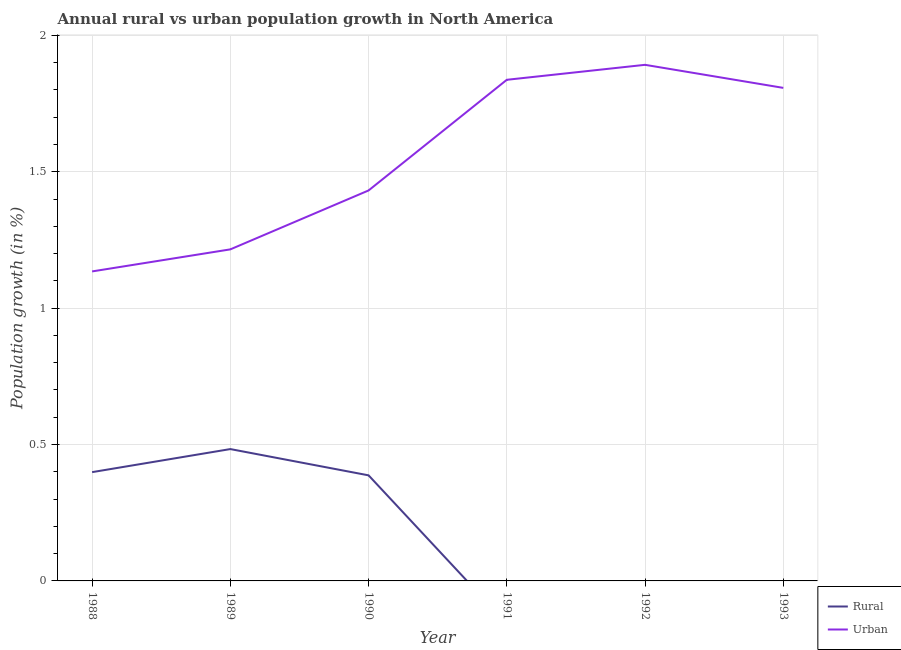Does the line corresponding to rural population growth intersect with the line corresponding to urban population growth?
Offer a terse response. No. What is the urban population growth in 1991?
Offer a very short reply. 1.84. Across all years, what is the maximum urban population growth?
Offer a terse response. 1.89. Across all years, what is the minimum rural population growth?
Your answer should be compact. 0. What is the total urban population growth in the graph?
Provide a succinct answer. 9.32. What is the difference between the urban population growth in 1989 and that in 1992?
Your answer should be very brief. -0.68. What is the difference between the rural population growth in 1990 and the urban population growth in 1992?
Give a very brief answer. -1.5. What is the average urban population growth per year?
Your answer should be compact. 1.55. In the year 1990, what is the difference between the rural population growth and urban population growth?
Your answer should be compact. -1.04. What is the ratio of the rural population growth in 1989 to that in 1990?
Your answer should be very brief. 1.25. Is the urban population growth in 1988 less than that in 1990?
Make the answer very short. Yes. What is the difference between the highest and the second highest urban population growth?
Provide a short and direct response. 0.05. What is the difference between the highest and the lowest rural population growth?
Your answer should be very brief. 0.48. In how many years, is the urban population growth greater than the average urban population growth taken over all years?
Provide a succinct answer. 3. Is the sum of the rural population growth in 1989 and 1990 greater than the maximum urban population growth across all years?
Make the answer very short. No. How many lines are there?
Offer a terse response. 2. How many years are there in the graph?
Keep it short and to the point. 6. Where does the legend appear in the graph?
Your answer should be compact. Bottom right. How are the legend labels stacked?
Ensure brevity in your answer.  Vertical. What is the title of the graph?
Your response must be concise. Annual rural vs urban population growth in North America. Does "Primary school" appear as one of the legend labels in the graph?
Make the answer very short. No. What is the label or title of the X-axis?
Your answer should be compact. Year. What is the label or title of the Y-axis?
Keep it short and to the point. Population growth (in %). What is the Population growth (in %) of Rural in 1988?
Provide a short and direct response. 0.4. What is the Population growth (in %) of Urban  in 1988?
Provide a succinct answer. 1.13. What is the Population growth (in %) in Rural in 1989?
Give a very brief answer. 0.48. What is the Population growth (in %) of Urban  in 1989?
Your answer should be very brief. 1.22. What is the Population growth (in %) in Rural in 1990?
Offer a terse response. 0.39. What is the Population growth (in %) in Urban  in 1990?
Offer a terse response. 1.43. What is the Population growth (in %) of Urban  in 1991?
Ensure brevity in your answer.  1.84. What is the Population growth (in %) in Rural in 1992?
Provide a succinct answer. 0. What is the Population growth (in %) in Urban  in 1992?
Offer a very short reply. 1.89. What is the Population growth (in %) of Rural in 1993?
Give a very brief answer. 0. What is the Population growth (in %) of Urban  in 1993?
Your answer should be compact. 1.81. Across all years, what is the maximum Population growth (in %) in Rural?
Offer a very short reply. 0.48. Across all years, what is the maximum Population growth (in %) in Urban ?
Provide a succinct answer. 1.89. Across all years, what is the minimum Population growth (in %) in Urban ?
Make the answer very short. 1.13. What is the total Population growth (in %) in Rural in the graph?
Keep it short and to the point. 1.27. What is the total Population growth (in %) of Urban  in the graph?
Make the answer very short. 9.32. What is the difference between the Population growth (in %) of Rural in 1988 and that in 1989?
Your answer should be compact. -0.08. What is the difference between the Population growth (in %) of Urban  in 1988 and that in 1989?
Your answer should be compact. -0.08. What is the difference between the Population growth (in %) of Rural in 1988 and that in 1990?
Your answer should be very brief. 0.01. What is the difference between the Population growth (in %) of Urban  in 1988 and that in 1990?
Ensure brevity in your answer.  -0.3. What is the difference between the Population growth (in %) in Urban  in 1988 and that in 1991?
Offer a terse response. -0.7. What is the difference between the Population growth (in %) in Urban  in 1988 and that in 1992?
Make the answer very short. -0.76. What is the difference between the Population growth (in %) in Urban  in 1988 and that in 1993?
Your answer should be compact. -0.67. What is the difference between the Population growth (in %) of Rural in 1989 and that in 1990?
Provide a short and direct response. 0.1. What is the difference between the Population growth (in %) in Urban  in 1989 and that in 1990?
Your answer should be compact. -0.22. What is the difference between the Population growth (in %) of Urban  in 1989 and that in 1991?
Ensure brevity in your answer.  -0.62. What is the difference between the Population growth (in %) of Urban  in 1989 and that in 1992?
Offer a very short reply. -0.68. What is the difference between the Population growth (in %) of Urban  in 1989 and that in 1993?
Provide a succinct answer. -0.59. What is the difference between the Population growth (in %) in Urban  in 1990 and that in 1991?
Your answer should be very brief. -0.41. What is the difference between the Population growth (in %) of Urban  in 1990 and that in 1992?
Keep it short and to the point. -0.46. What is the difference between the Population growth (in %) of Urban  in 1990 and that in 1993?
Offer a terse response. -0.38. What is the difference between the Population growth (in %) of Urban  in 1991 and that in 1992?
Make the answer very short. -0.05. What is the difference between the Population growth (in %) of Urban  in 1991 and that in 1993?
Your response must be concise. 0.03. What is the difference between the Population growth (in %) in Urban  in 1992 and that in 1993?
Offer a very short reply. 0.08. What is the difference between the Population growth (in %) of Rural in 1988 and the Population growth (in %) of Urban  in 1989?
Offer a terse response. -0.82. What is the difference between the Population growth (in %) of Rural in 1988 and the Population growth (in %) of Urban  in 1990?
Offer a very short reply. -1.03. What is the difference between the Population growth (in %) in Rural in 1988 and the Population growth (in %) in Urban  in 1991?
Your answer should be very brief. -1.44. What is the difference between the Population growth (in %) in Rural in 1988 and the Population growth (in %) in Urban  in 1992?
Give a very brief answer. -1.49. What is the difference between the Population growth (in %) in Rural in 1988 and the Population growth (in %) in Urban  in 1993?
Provide a succinct answer. -1.41. What is the difference between the Population growth (in %) of Rural in 1989 and the Population growth (in %) of Urban  in 1990?
Make the answer very short. -0.95. What is the difference between the Population growth (in %) of Rural in 1989 and the Population growth (in %) of Urban  in 1991?
Offer a very short reply. -1.35. What is the difference between the Population growth (in %) in Rural in 1989 and the Population growth (in %) in Urban  in 1992?
Give a very brief answer. -1.41. What is the difference between the Population growth (in %) in Rural in 1989 and the Population growth (in %) in Urban  in 1993?
Make the answer very short. -1.32. What is the difference between the Population growth (in %) in Rural in 1990 and the Population growth (in %) in Urban  in 1991?
Keep it short and to the point. -1.45. What is the difference between the Population growth (in %) in Rural in 1990 and the Population growth (in %) in Urban  in 1992?
Ensure brevity in your answer.  -1.5. What is the difference between the Population growth (in %) of Rural in 1990 and the Population growth (in %) of Urban  in 1993?
Provide a succinct answer. -1.42. What is the average Population growth (in %) in Rural per year?
Ensure brevity in your answer.  0.21. What is the average Population growth (in %) of Urban  per year?
Ensure brevity in your answer.  1.55. In the year 1988, what is the difference between the Population growth (in %) in Rural and Population growth (in %) in Urban ?
Provide a succinct answer. -0.74. In the year 1989, what is the difference between the Population growth (in %) of Rural and Population growth (in %) of Urban ?
Make the answer very short. -0.73. In the year 1990, what is the difference between the Population growth (in %) of Rural and Population growth (in %) of Urban ?
Provide a succinct answer. -1.04. What is the ratio of the Population growth (in %) in Rural in 1988 to that in 1989?
Keep it short and to the point. 0.83. What is the ratio of the Population growth (in %) of Urban  in 1988 to that in 1989?
Offer a very short reply. 0.93. What is the ratio of the Population growth (in %) of Rural in 1988 to that in 1990?
Your answer should be very brief. 1.03. What is the ratio of the Population growth (in %) of Urban  in 1988 to that in 1990?
Give a very brief answer. 0.79. What is the ratio of the Population growth (in %) of Urban  in 1988 to that in 1991?
Make the answer very short. 0.62. What is the ratio of the Population growth (in %) of Urban  in 1988 to that in 1992?
Your answer should be compact. 0.6. What is the ratio of the Population growth (in %) of Urban  in 1988 to that in 1993?
Offer a very short reply. 0.63. What is the ratio of the Population growth (in %) of Rural in 1989 to that in 1990?
Your answer should be very brief. 1.25. What is the ratio of the Population growth (in %) of Urban  in 1989 to that in 1990?
Ensure brevity in your answer.  0.85. What is the ratio of the Population growth (in %) of Urban  in 1989 to that in 1991?
Your answer should be very brief. 0.66. What is the ratio of the Population growth (in %) of Urban  in 1989 to that in 1992?
Offer a terse response. 0.64. What is the ratio of the Population growth (in %) of Urban  in 1989 to that in 1993?
Offer a terse response. 0.67. What is the ratio of the Population growth (in %) of Urban  in 1990 to that in 1991?
Your answer should be compact. 0.78. What is the ratio of the Population growth (in %) in Urban  in 1990 to that in 1992?
Give a very brief answer. 0.76. What is the ratio of the Population growth (in %) of Urban  in 1990 to that in 1993?
Your answer should be compact. 0.79. What is the ratio of the Population growth (in %) in Urban  in 1991 to that in 1993?
Keep it short and to the point. 1.02. What is the ratio of the Population growth (in %) in Urban  in 1992 to that in 1993?
Your response must be concise. 1.05. What is the difference between the highest and the second highest Population growth (in %) of Rural?
Offer a very short reply. 0.08. What is the difference between the highest and the second highest Population growth (in %) in Urban ?
Your answer should be very brief. 0.05. What is the difference between the highest and the lowest Population growth (in %) in Rural?
Make the answer very short. 0.48. What is the difference between the highest and the lowest Population growth (in %) of Urban ?
Your answer should be compact. 0.76. 